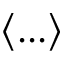<formula> <loc_0><loc_0><loc_500><loc_500>\left \langle \dots \right \rangle</formula> 